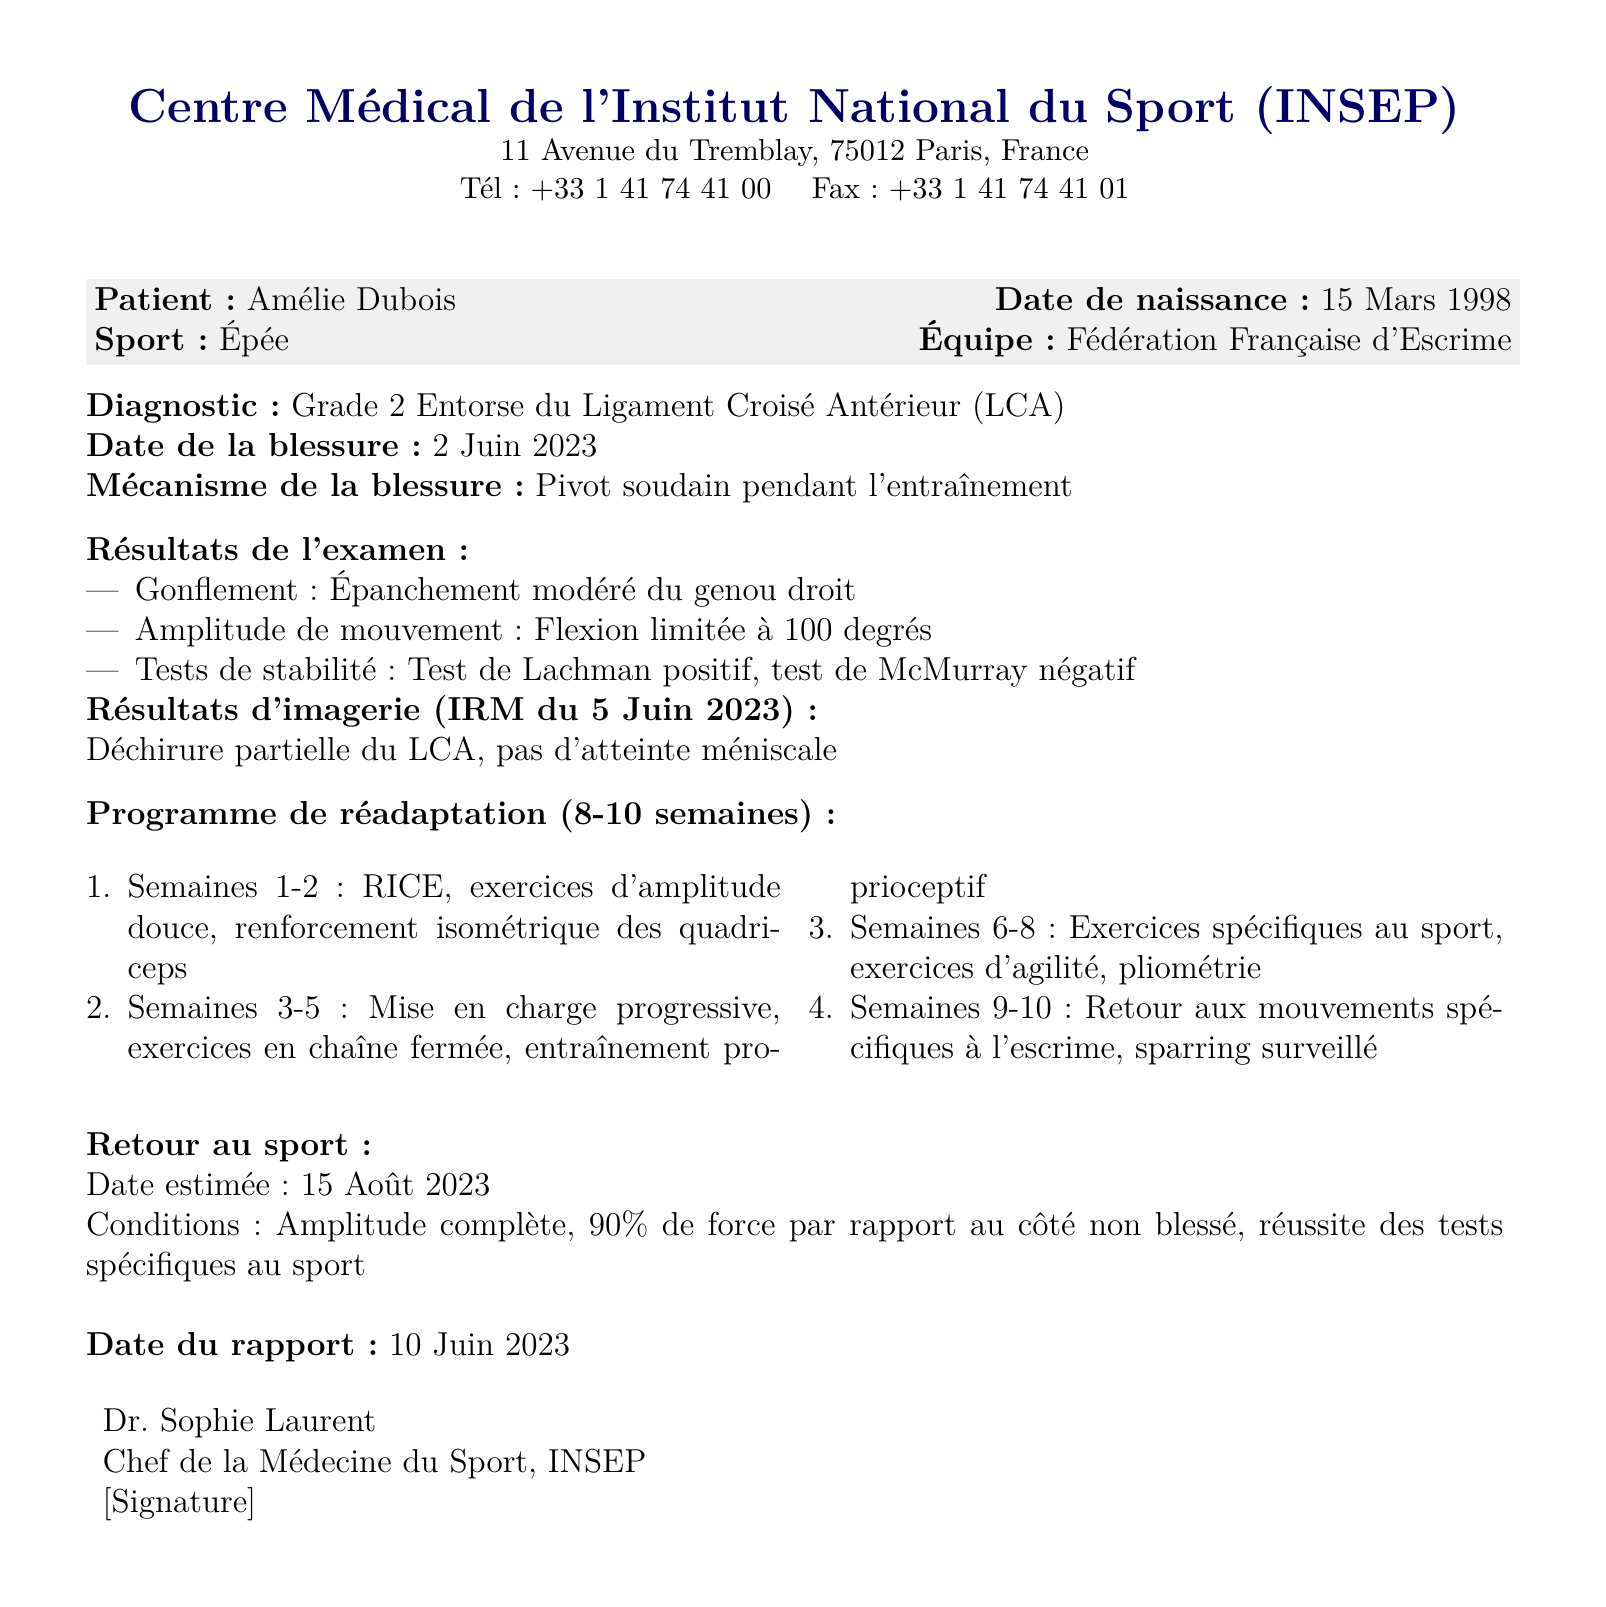Quel est le diagnostic ? Le diagnostic est mentionné sous "Diagnostic" dans le document et indique le type de blessure.
Answer: Grade 2 Entorse du Ligament Croisé Antérieur (LCA) Quelle est la date de la blessure ? La date de la blessure est spécifiée juste après le diagnostic dans le document.
Answer: 2 Juin 2023 Qui a signé le rapport ? Le nom du médecin qui a signé le rapport est indiqué à la fin du document.
Answer: Dr. Sophie Laurent Quel est le programme de réhabilitation pour les semaines 1-2 ? Le programme de réhabilitation est détaillé sous la section correspondante et spécifie les premières étapes.
Answer: RICE, exercices d'amplitude douce, renforcement isométrique des quadriceps Quelle est la date estimée de retour au sport ? Cette information est précisée dans la section "Retour au sport" et indique la date prévue.
Answer: 15 Août 2023 Quel type d'examens ont été effectués ? Les examens réalisés sont précisés sous "Résultats de l'examen" et énumèrent divers aspects de l'évaluation.
Answer: Gonflement, Amplitude de mouvement, Tests de stabilité Quelle est la condition pour le retour au sport ? Les conditions sont listées dans la section "Retour au sport" et spécifient ce qui est requis avant de reprendre.
Answer: Amplitude complète, 90% de force par rapport au côté non blessé, réussite des tests spécifiques au sport Quel est le lieu de la clinique ? Le lieu du centre médical est mentionné en haut du document.
Answer: 11 Avenue du Tremblay, 75012 Paris, France 